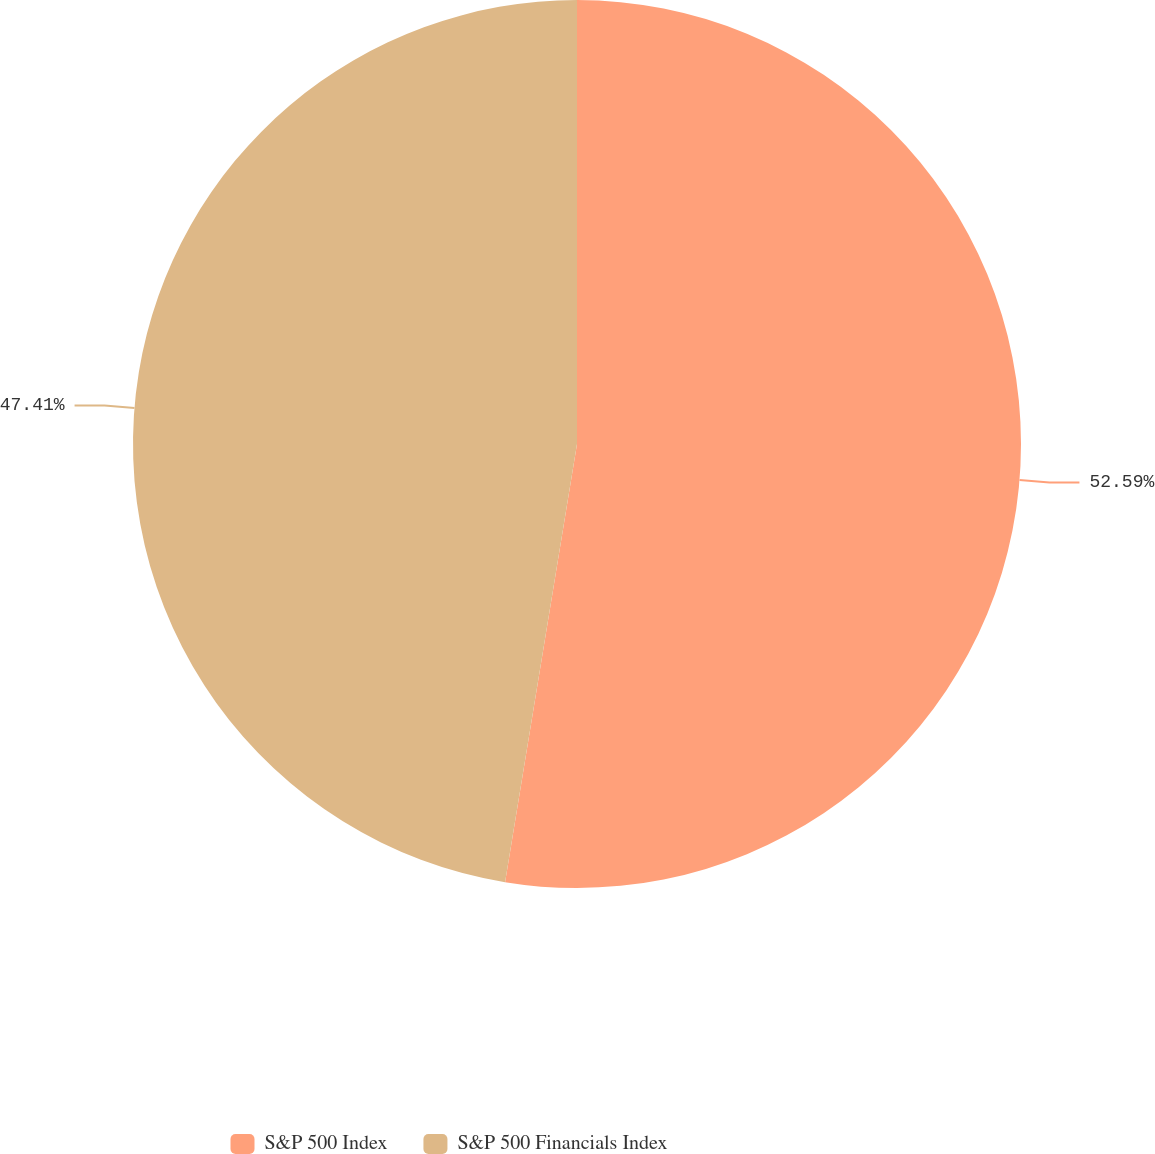<chart> <loc_0><loc_0><loc_500><loc_500><pie_chart><fcel>S&P 500 Index<fcel>S&P 500 Financials Index<nl><fcel>52.59%<fcel>47.41%<nl></chart> 